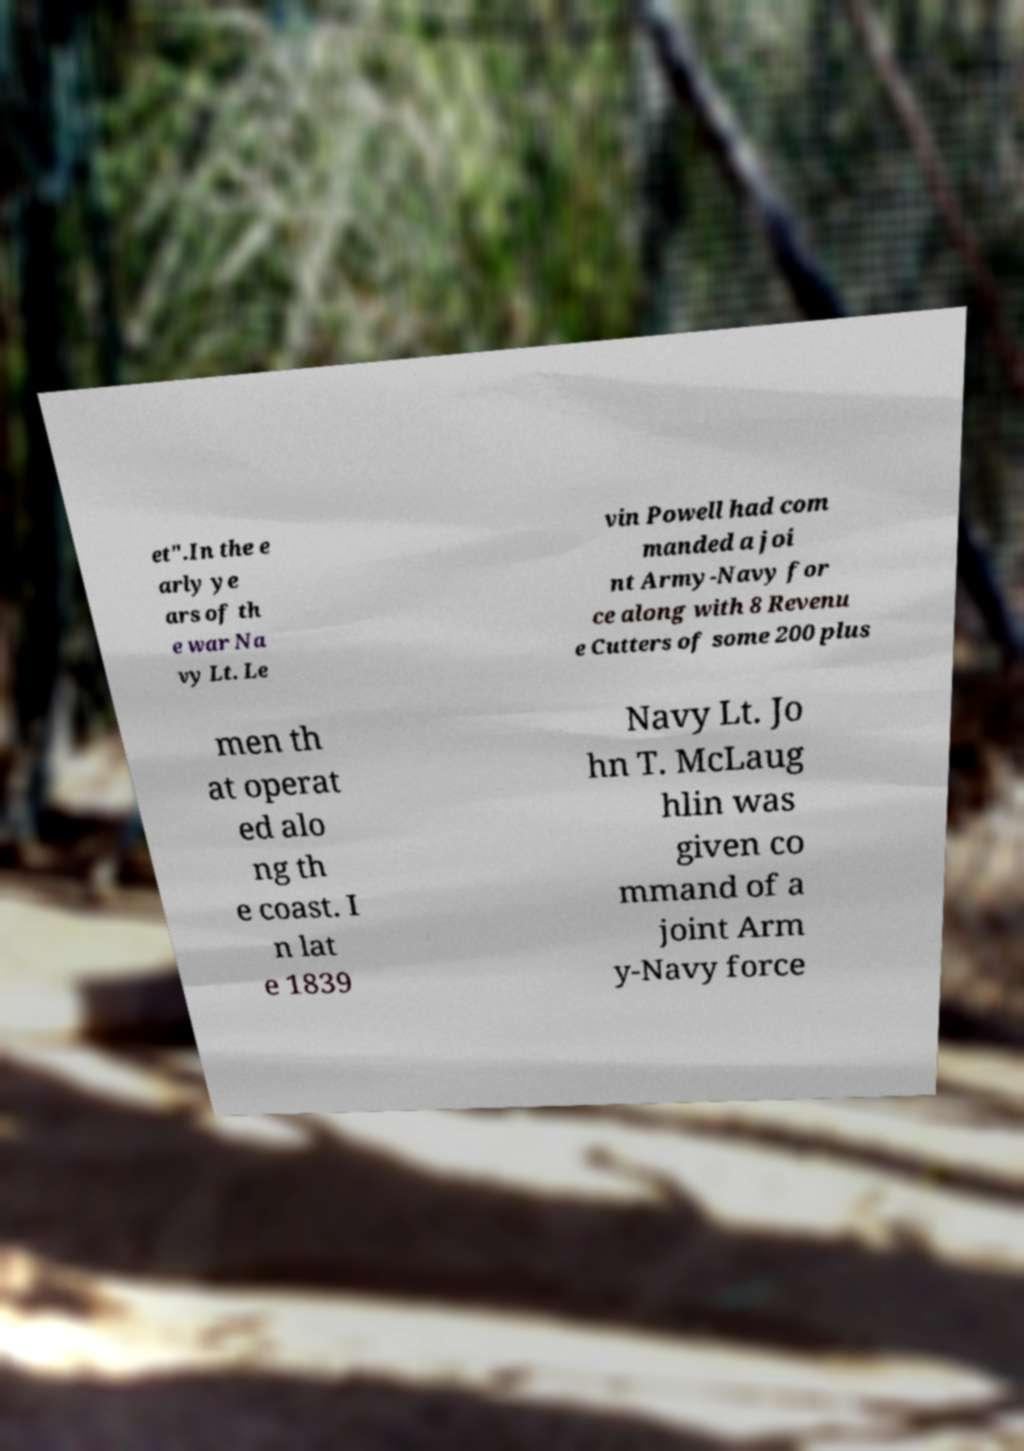I need the written content from this picture converted into text. Can you do that? et".In the e arly ye ars of th e war Na vy Lt. Le vin Powell had com manded a joi nt Army-Navy for ce along with 8 Revenu e Cutters of some 200 plus men th at operat ed alo ng th e coast. I n lat e 1839 Navy Lt. Jo hn T. McLaug hlin was given co mmand of a joint Arm y-Navy force 